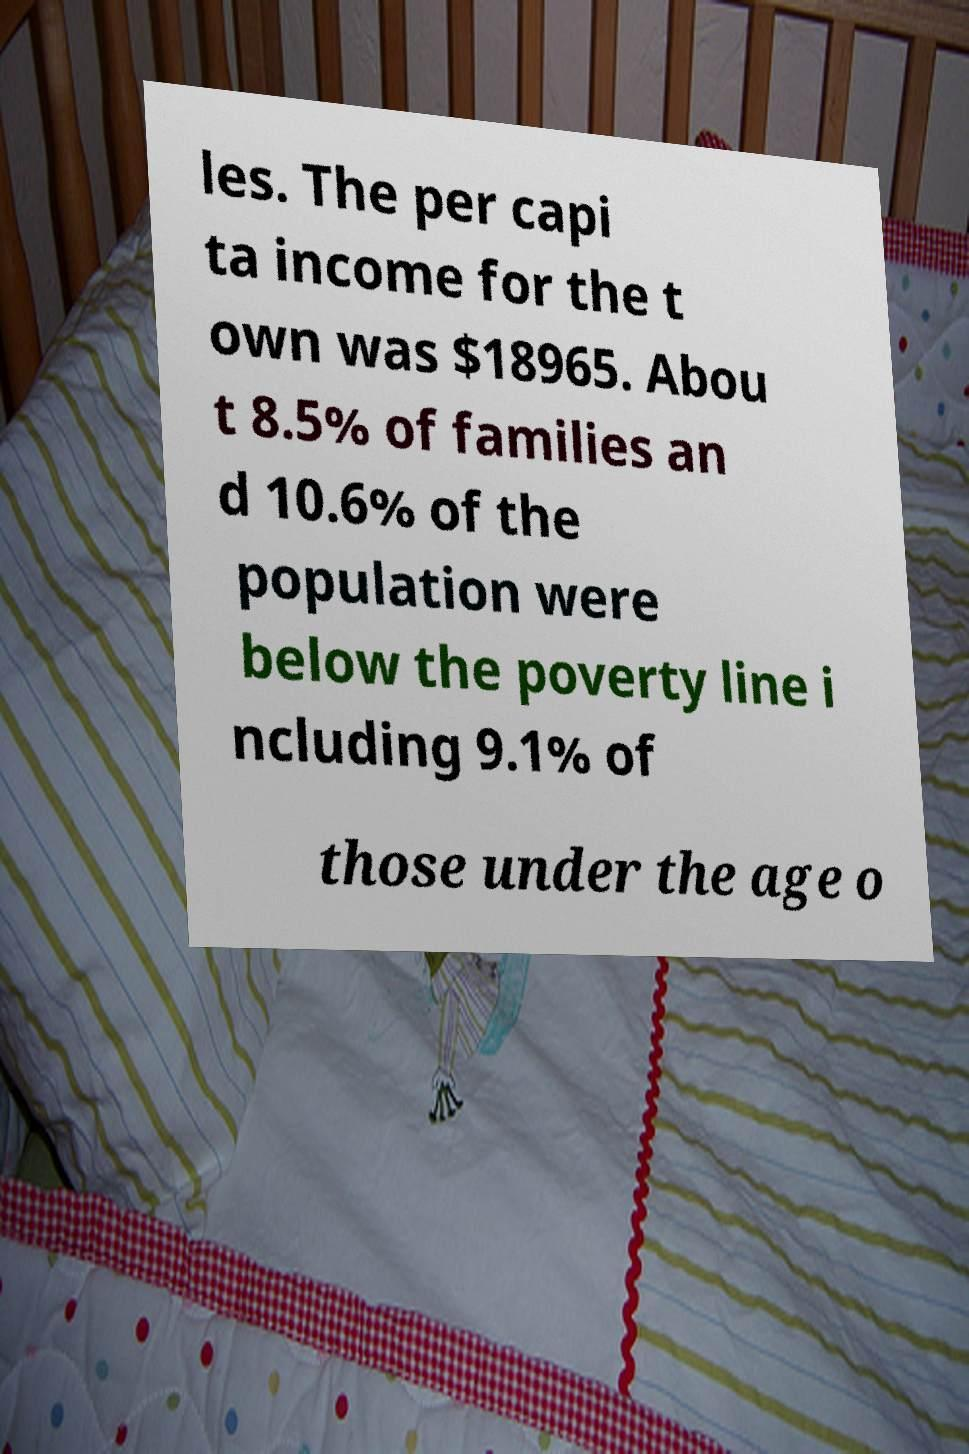Please identify and transcribe the text found in this image. les. The per capi ta income for the t own was $18965. Abou t 8.5% of families an d 10.6% of the population were below the poverty line i ncluding 9.1% of those under the age o 